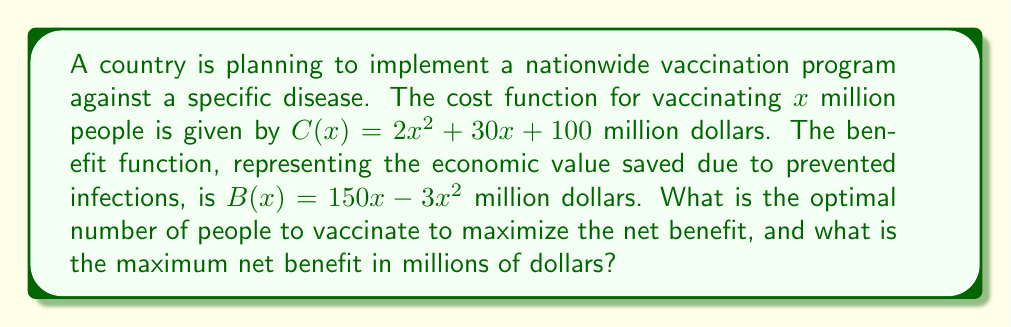Solve this math problem. To solve this problem, we'll follow these steps:

1) The net benefit function is the difference between the benefit and cost functions:
   $N(x) = B(x) - C(x) = (150x - 3x^2) - (2x^2 + 30x + 100)$
   $N(x) = -5x^2 + 120x - 100$

2) To find the maximum of this quadratic function, we need to find where its derivative equals zero:
   $N'(x) = -10x + 120$
   Set this equal to zero: $-10x + 120 = 0$
   Solve for x: $x = 12$

3) Verify this is a maximum by checking the second derivative:
   $N''(x) = -10$, which is negative, confirming a maximum.

4) The optimal number of people to vaccinate is 12 million.

5) To find the maximum net benefit, plug x = 12 into the net benefit function:
   $N(12) = -5(12)^2 + 120(12) - 100$
   $= -720 + 1440 - 100$
   $= 620$

Therefore, the maximum net benefit is 620 million dollars.
Answer: Optimal number to vaccinate: 12 million people; Maximum net benefit: $620 million 